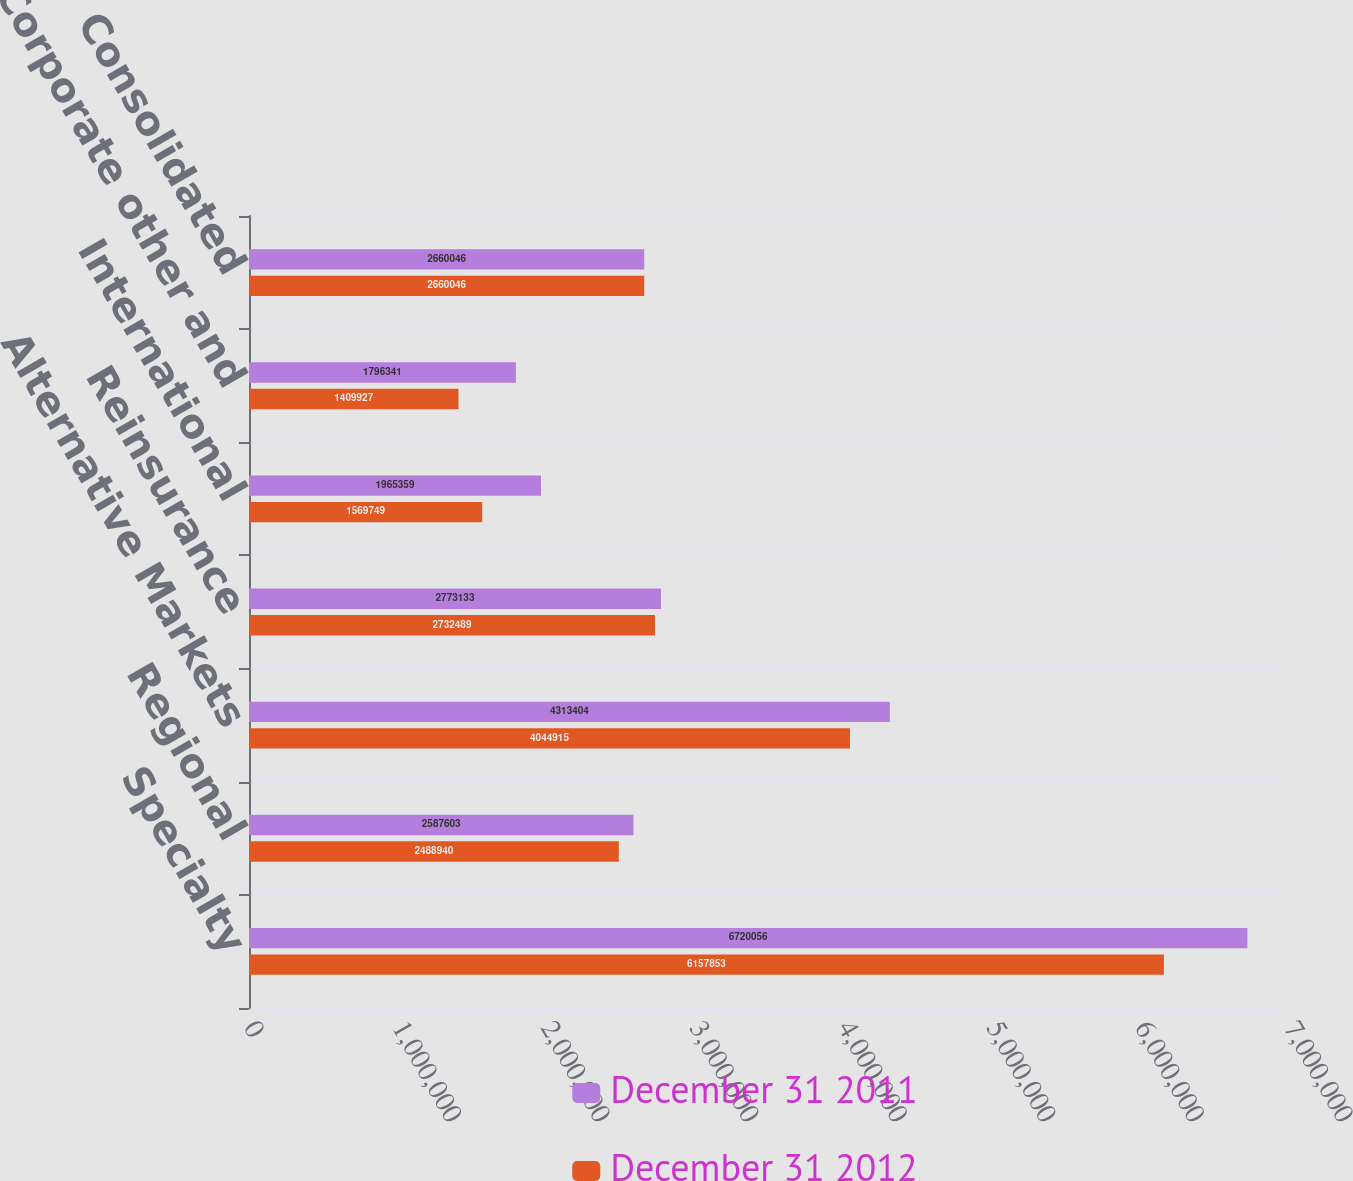Convert chart to OTSL. <chart><loc_0><loc_0><loc_500><loc_500><stacked_bar_chart><ecel><fcel>Specialty<fcel>Regional<fcel>Alternative Markets<fcel>Reinsurance<fcel>International<fcel>Corporate other and<fcel>Consolidated<nl><fcel>December 31 2011<fcel>6.72006e+06<fcel>2.5876e+06<fcel>4.3134e+06<fcel>2.77313e+06<fcel>1.96536e+06<fcel>1.79634e+06<fcel>2.66005e+06<nl><fcel>December 31 2012<fcel>6.15785e+06<fcel>2.48894e+06<fcel>4.04492e+06<fcel>2.73249e+06<fcel>1.56975e+06<fcel>1.40993e+06<fcel>2.66005e+06<nl></chart> 